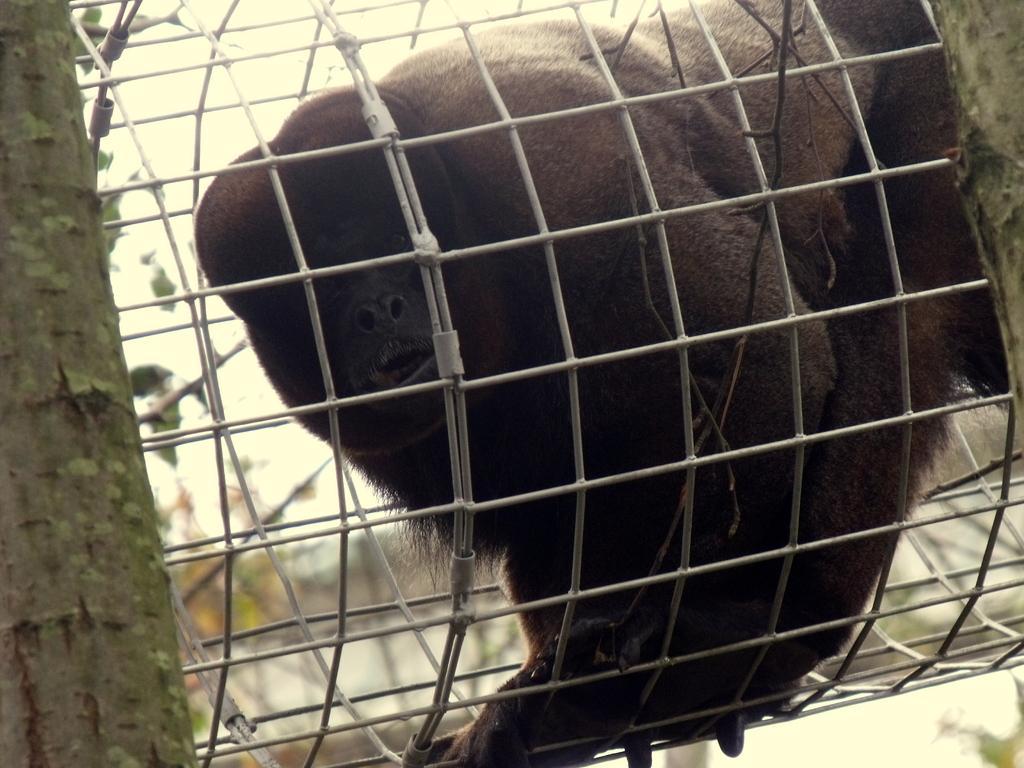In one or two sentences, can you explain what this image depicts? Here in this picture we can see a chimpanzee present in a cage over there and we can also see trees present here and there. 